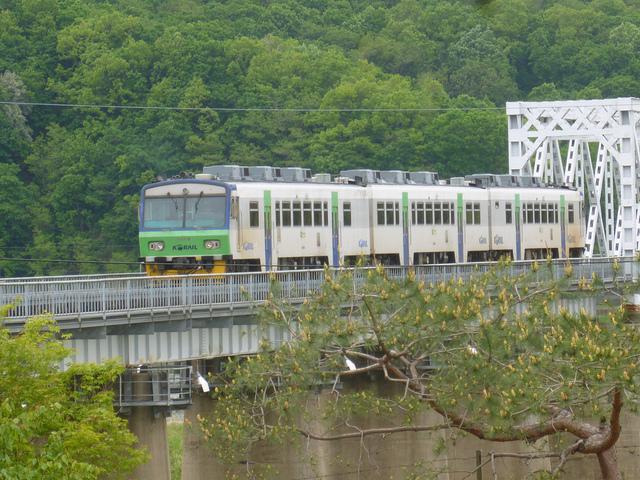How many cars are there?
Give a very brief answer. 3. Where is the train traveling too?
Quick response, please. Across bridge. Is there more than one train?
Be succinct. No. 